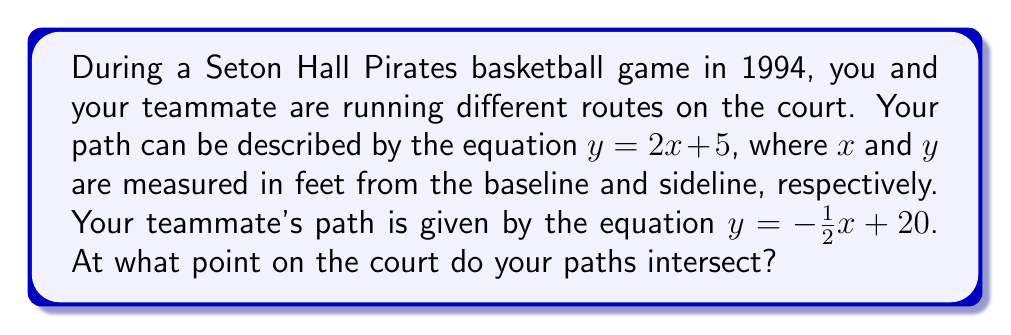Could you help me with this problem? To find the intersection point of the two paths, we need to solve the system of equations:

$$\begin{cases}
y = 2x + 5 \\
y = -\frac{1}{2}x + 20
\end{cases}$$

1) Since both equations are equal to $y$, we can set them equal to each other:

   $2x + 5 = -\frac{1}{2}x + 20$

2) Add $\frac{1}{2}x$ to both sides:

   $\frac{5}{2}x + 5 = 20$

3) Subtract 5 from both sides:

   $\frac{5}{2}x = 15$

4) Multiply both sides by $\frac{2}{5}$:

   $x = 6$

5) Now that we know $x$, we can substitute it into either of the original equations. Let's use the first one:

   $y = 2(6) + 5 = 12 + 5 = 17$

Therefore, the intersection point is $(6, 17)$.
Answer: $(6, 17)$ feet from the baseline and sideline, respectively. 